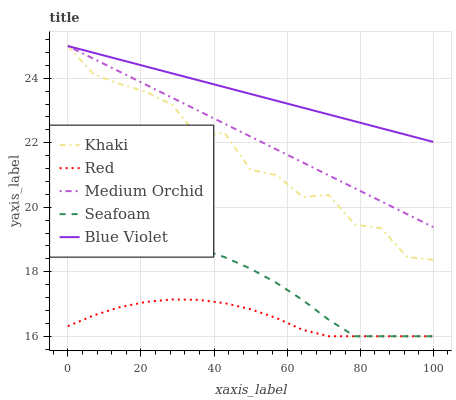Does Red have the minimum area under the curve?
Answer yes or no. Yes. Does Blue Violet have the maximum area under the curve?
Answer yes or no. Yes. Does Medium Orchid have the minimum area under the curve?
Answer yes or no. No. Does Medium Orchid have the maximum area under the curve?
Answer yes or no. No. Is Blue Violet the smoothest?
Answer yes or no. Yes. Is Khaki the roughest?
Answer yes or no. Yes. Is Medium Orchid the smoothest?
Answer yes or no. No. Is Medium Orchid the roughest?
Answer yes or no. No. Does Medium Orchid have the lowest value?
Answer yes or no. No. Does Khaki have the highest value?
Answer yes or no. Yes. Does Seafoam have the highest value?
Answer yes or no. No. Is Red less than Blue Violet?
Answer yes or no. Yes. Is Blue Violet greater than Red?
Answer yes or no. Yes. Does Khaki intersect Blue Violet?
Answer yes or no. Yes. Is Khaki less than Blue Violet?
Answer yes or no. No. Is Khaki greater than Blue Violet?
Answer yes or no. No. Does Red intersect Blue Violet?
Answer yes or no. No. 